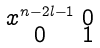<formula> <loc_0><loc_0><loc_500><loc_500>\begin{smallmatrix} x ^ { n - 2 l - 1 } & 0 \\ 0 & 1 \end{smallmatrix}</formula> 